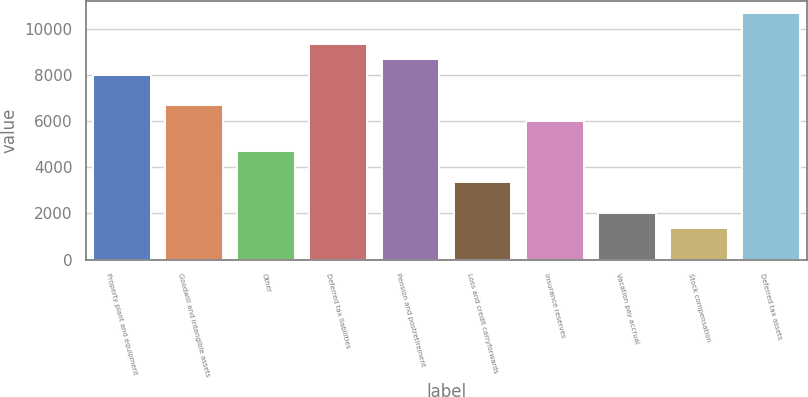Convert chart to OTSL. <chart><loc_0><loc_0><loc_500><loc_500><bar_chart><fcel>Property plant and equipment<fcel>Goodwill and intangible assets<fcel>Other<fcel>Deferred tax liabilities<fcel>Pension and postretirement<fcel>Loss and credit carryforwards<fcel>Insurance reserves<fcel>Vacation pay accrual<fcel>Stock compensation<fcel>Deferred tax assets<nl><fcel>8007.6<fcel>6679<fcel>4686.1<fcel>9336.2<fcel>8671.9<fcel>3357.5<fcel>6014.7<fcel>2028.9<fcel>1364.6<fcel>10664.8<nl></chart> 